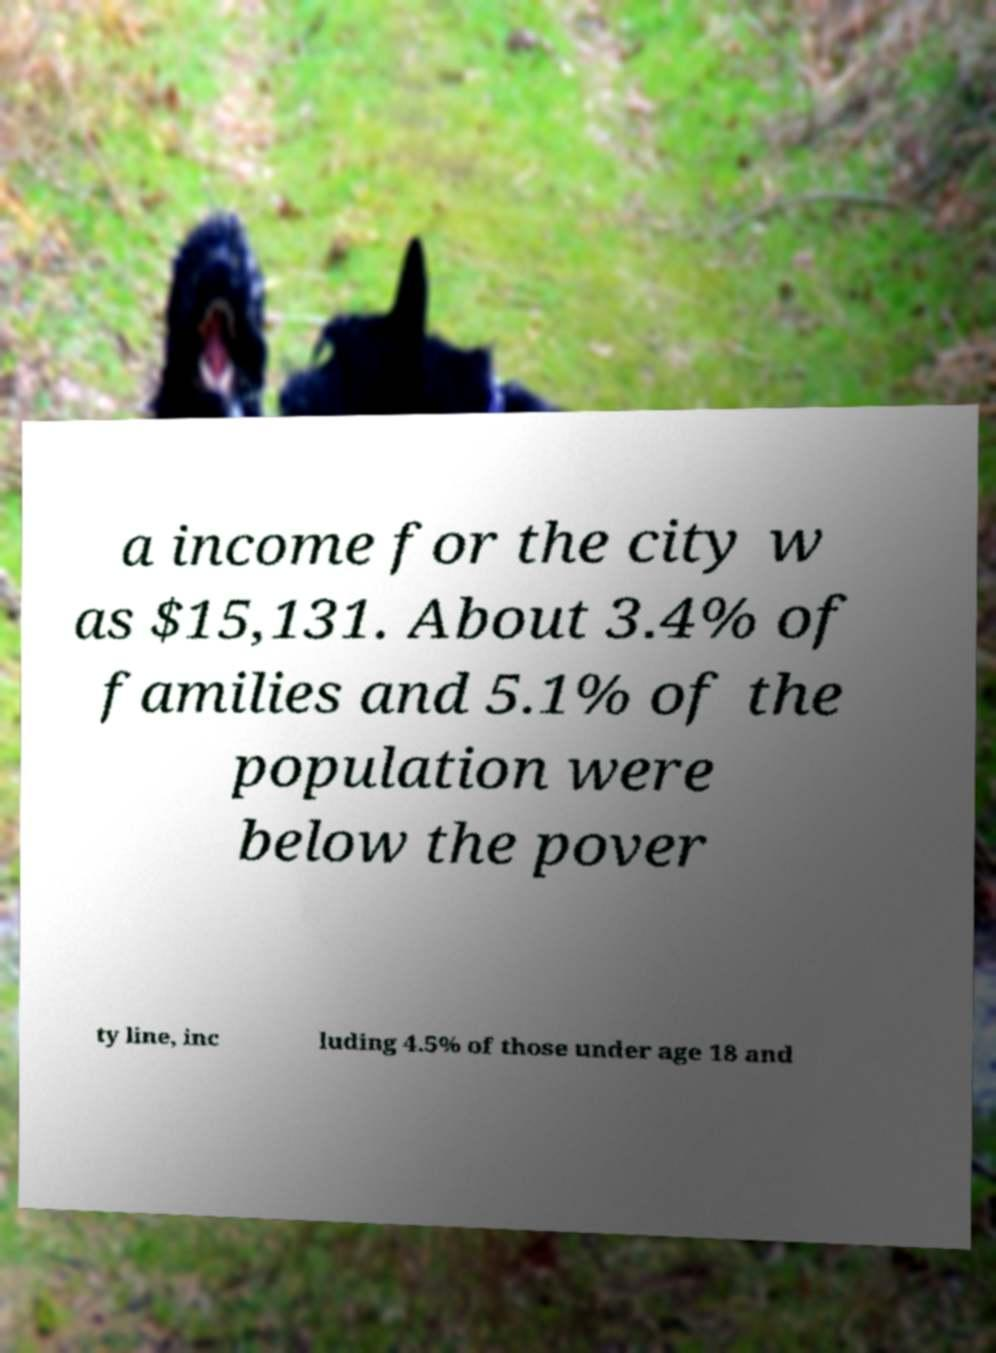Please identify and transcribe the text found in this image. a income for the city w as $15,131. About 3.4% of families and 5.1% of the population were below the pover ty line, inc luding 4.5% of those under age 18 and 